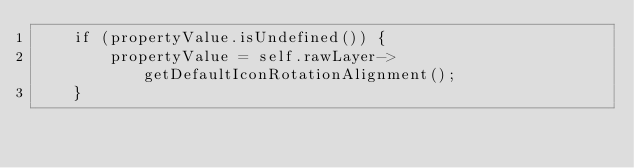<code> <loc_0><loc_0><loc_500><loc_500><_ObjectiveC_>    if (propertyValue.isUndefined()) {
        propertyValue = self.rawLayer->getDefaultIconRotationAlignment();
    }</code> 